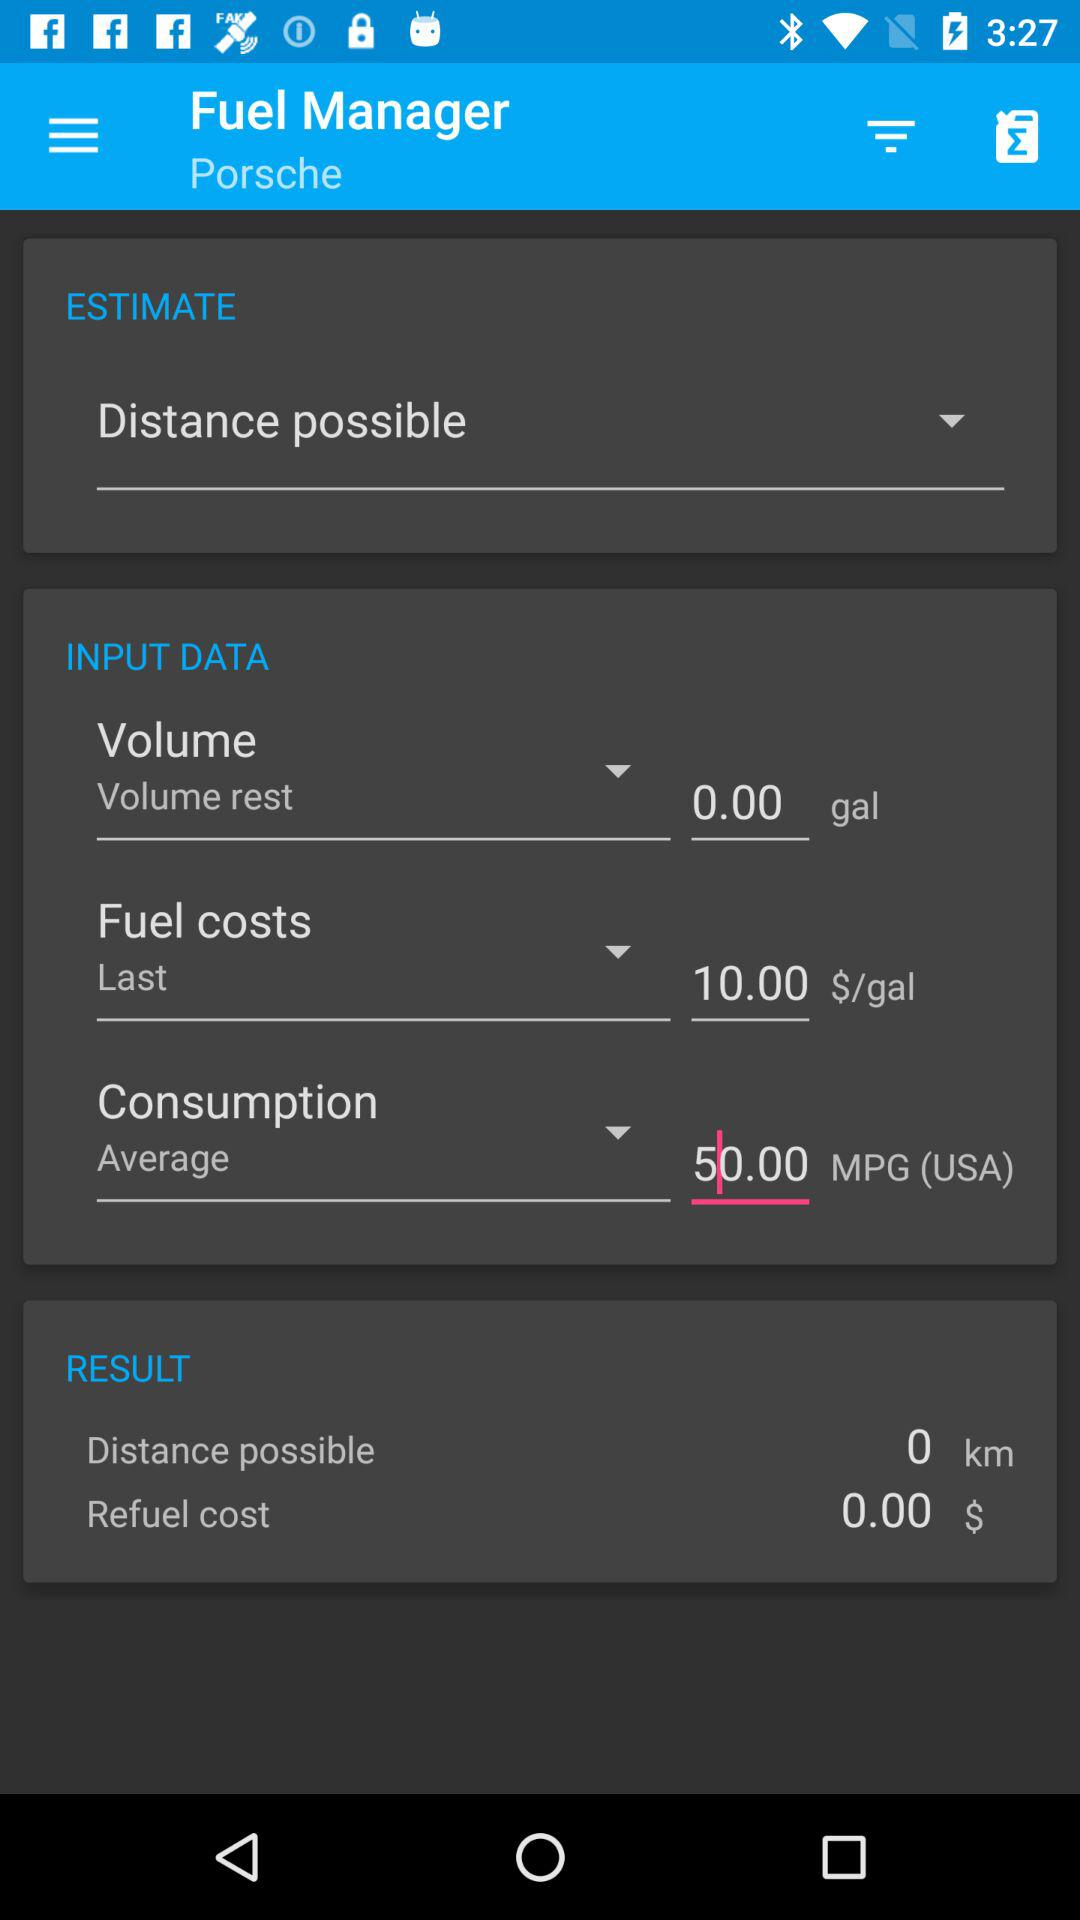What is the possible distance? The possible distance is 0 km. 